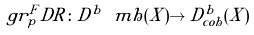Convert formula to latex. <formula><loc_0><loc_0><loc_500><loc_500>g r ^ { F } _ { p } D R \colon D ^ { b } \ m h ( X ) \to D ^ { b } _ { c o h } ( X )</formula> 